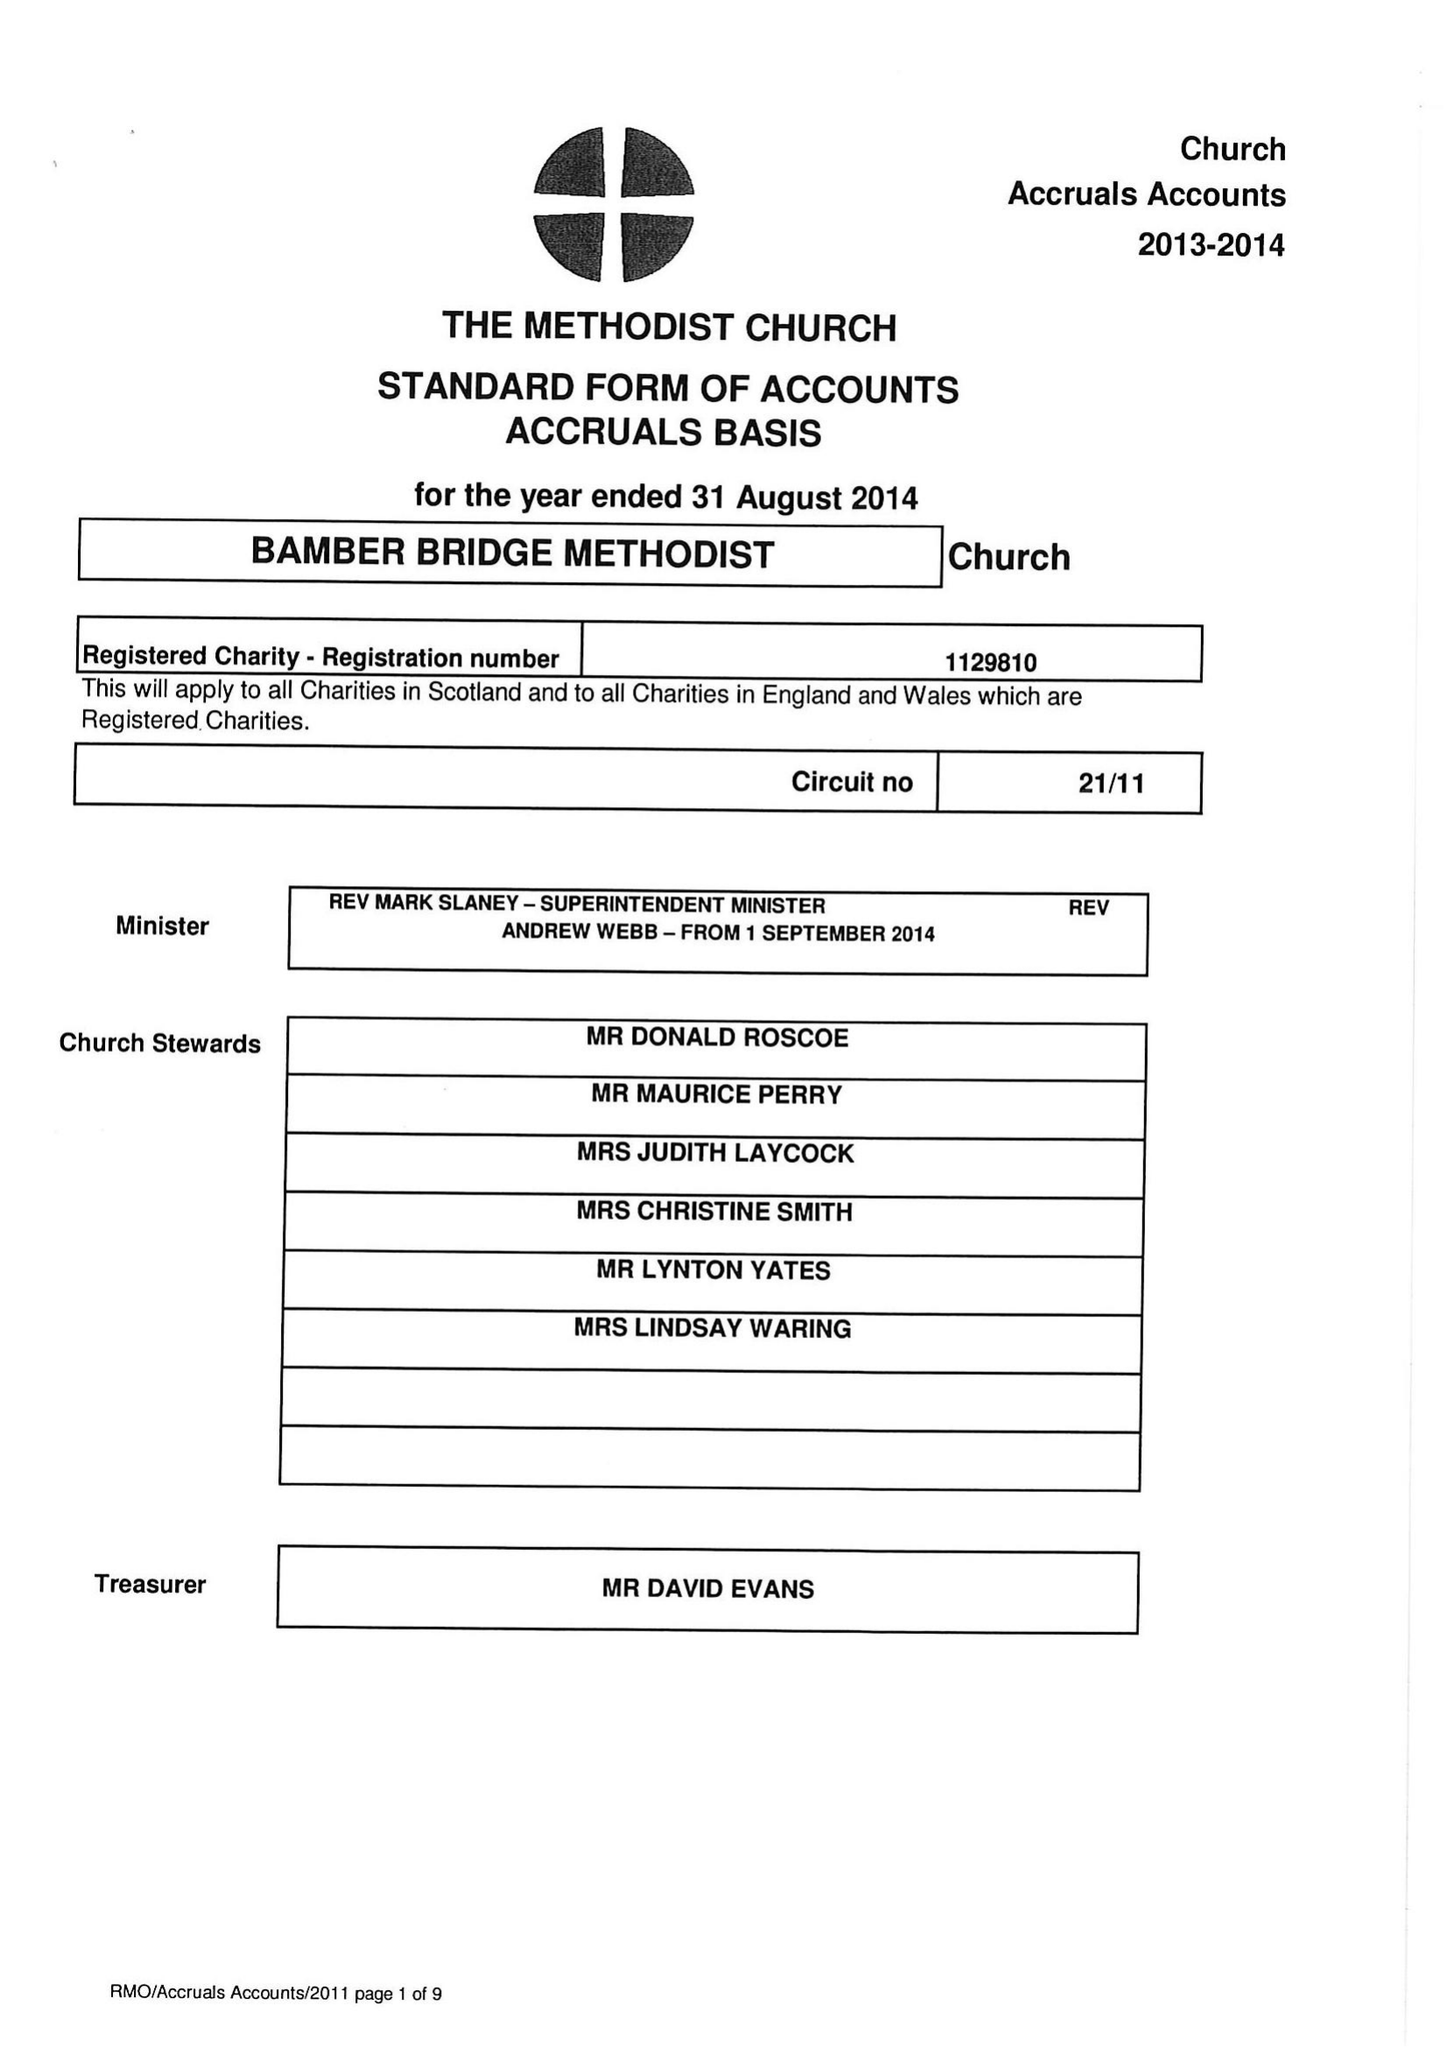What is the value for the address__street_line?
Answer the question using a single word or phrase. STATION ROAD 